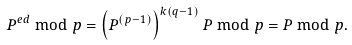Convert formula to latex. <formula><loc_0><loc_0><loc_500><loc_500>P ^ { e d } \bmod p = \left ( P ^ { ( p - 1 ) } \right ) ^ { k ( q - 1 ) } P \bmod p = P \bmod p .</formula> 